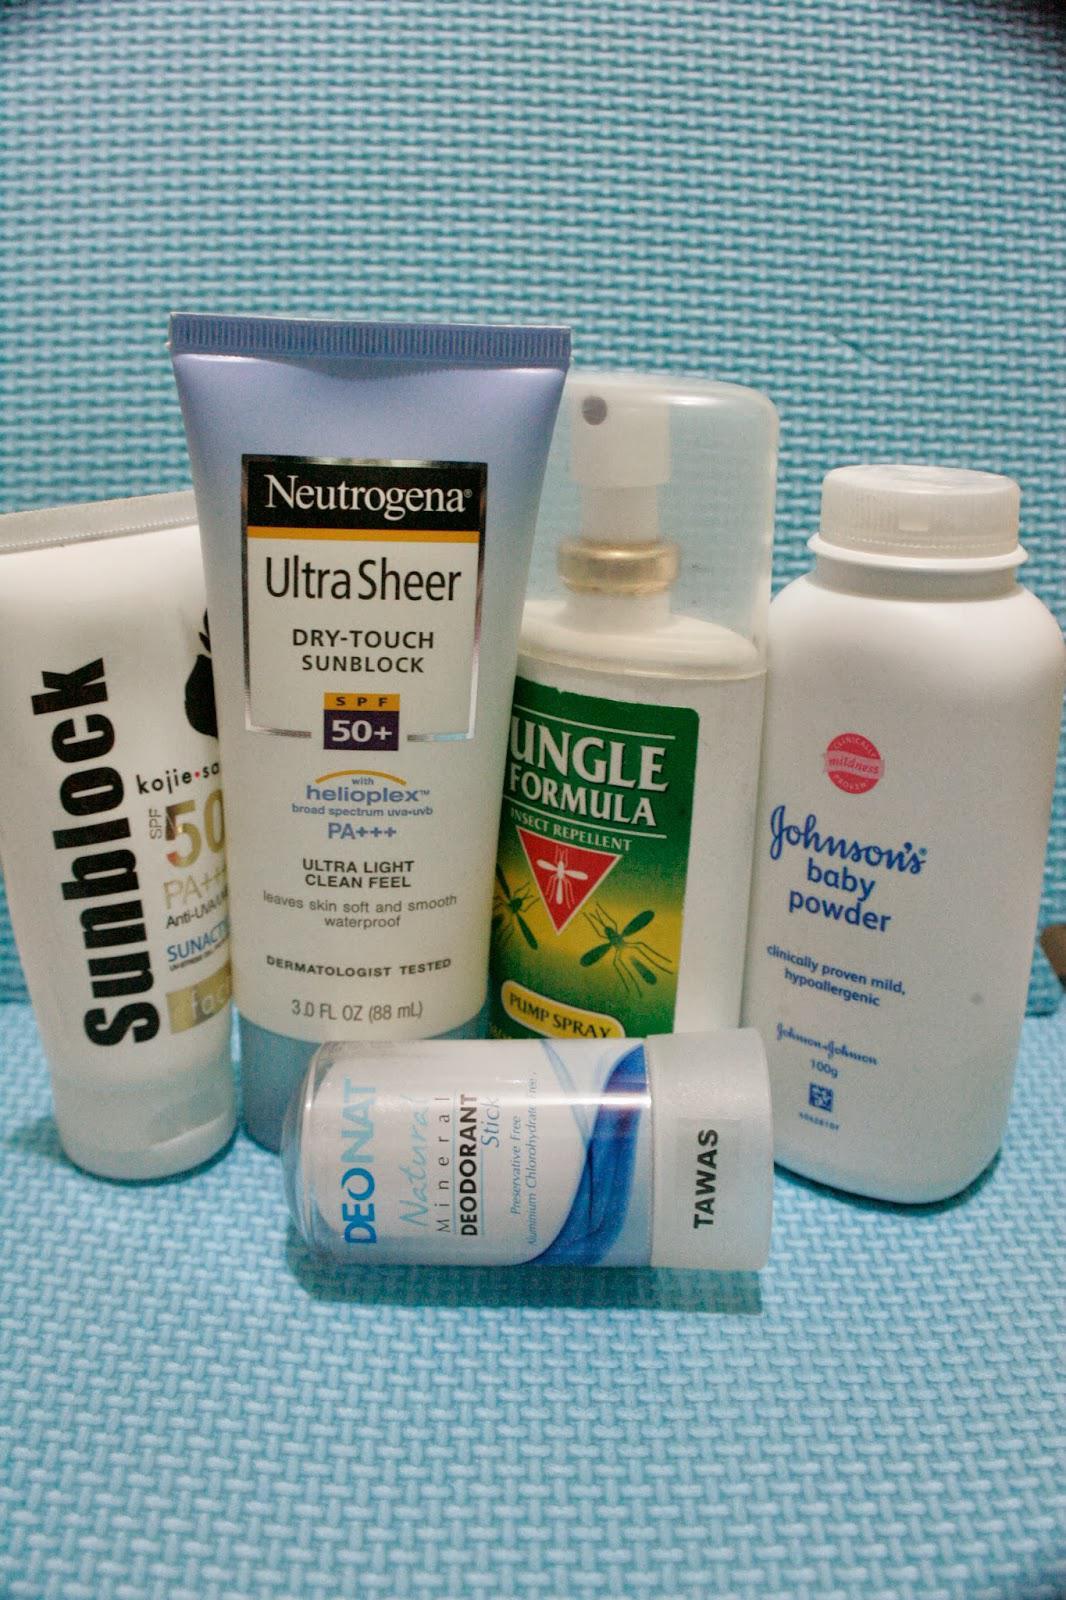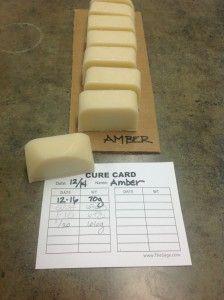The first image is the image on the left, the second image is the image on the right. For the images shown, is this caption "A circular bar of soap has a bee imprinted on it." true? Answer yes or no. No. 